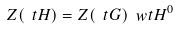Convert formula to latex. <formula><loc_0><loc_0><loc_500><loc_500>Z ( \ t H ) = Z ( \ t G ) \ w t { H ^ { 0 } }</formula> 